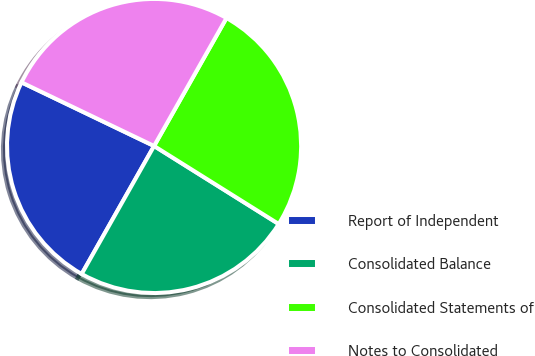Convert chart. <chart><loc_0><loc_0><loc_500><loc_500><pie_chart><fcel>Report of Independent<fcel>Consolidated Balance<fcel>Consolidated Statements of<fcel>Notes to Consolidated<nl><fcel>23.93%<fcel>24.29%<fcel>25.71%<fcel>26.07%<nl></chart> 